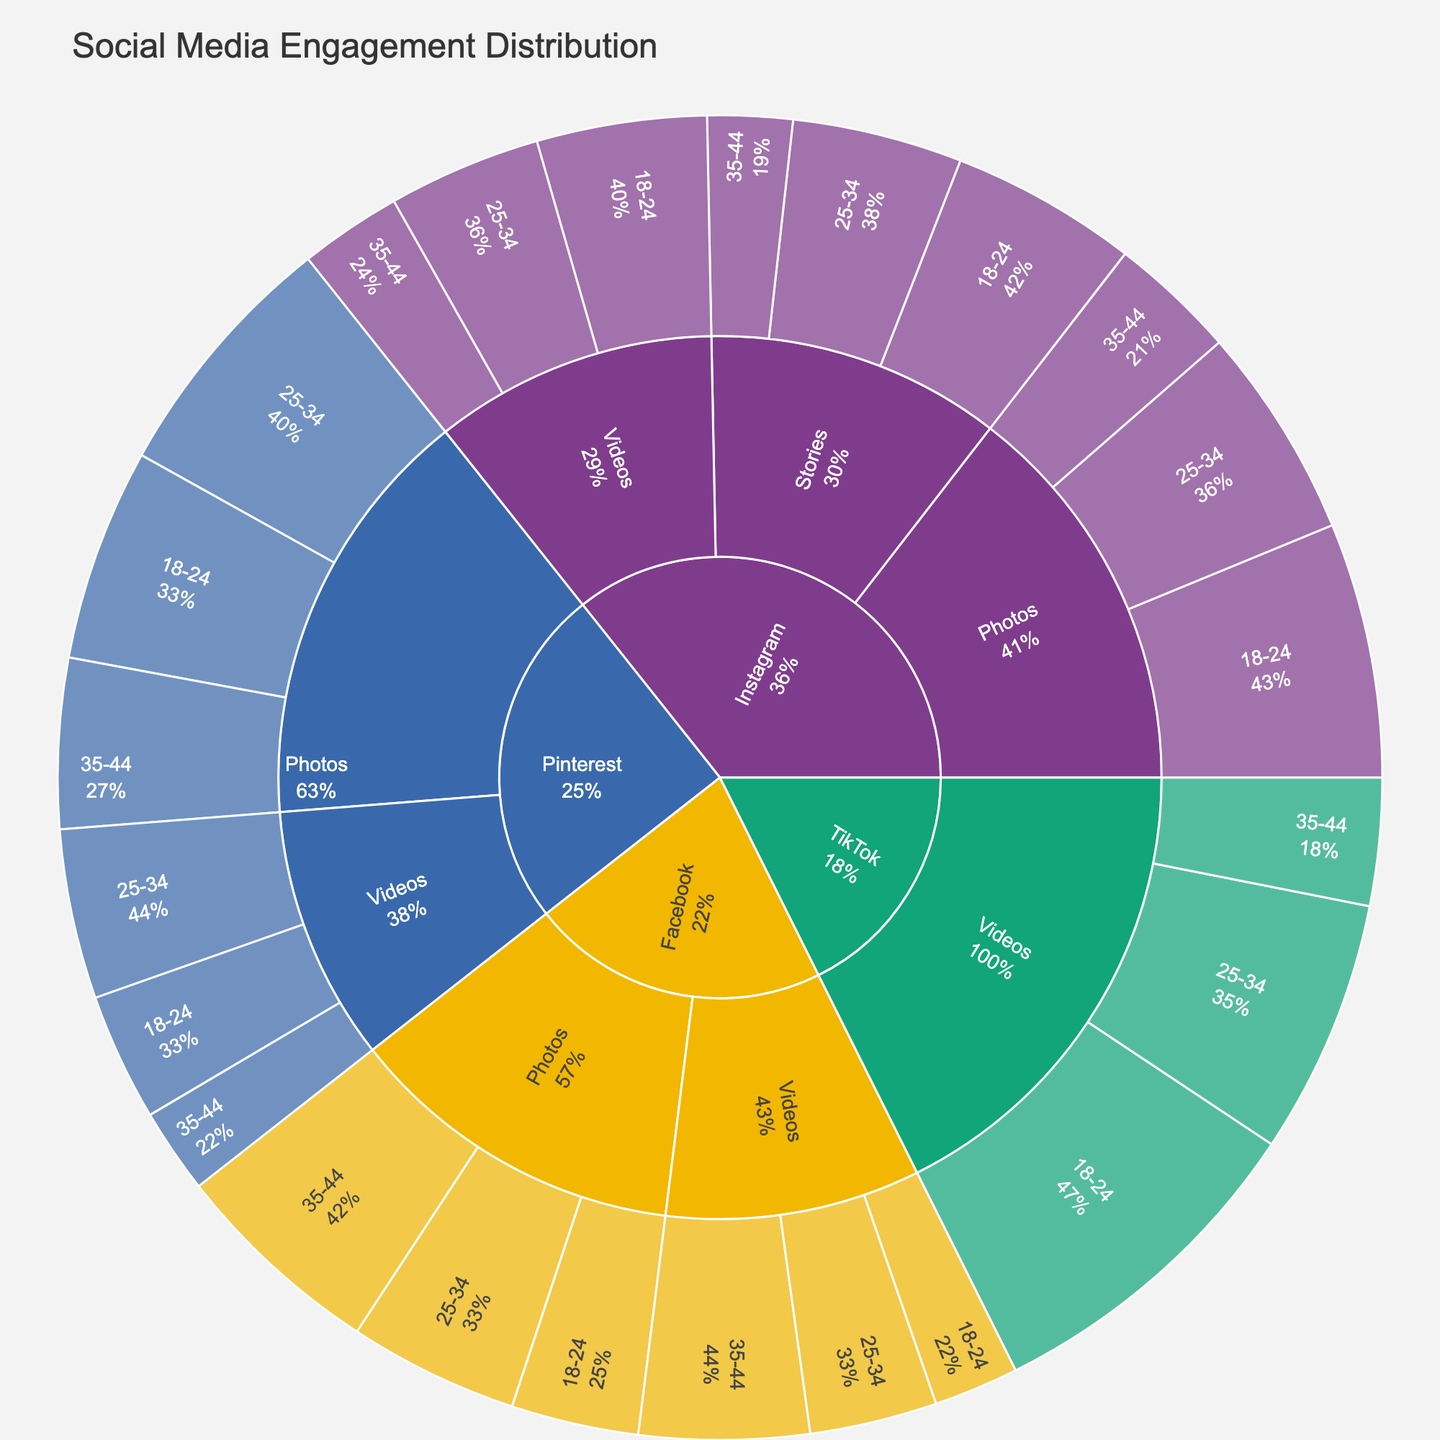what is the title of the plot? The title is displayed at the top of the plot. It summarizes the subject of the plot, providing context for what the data represents. In this case, it should be clearly visible as "Social Media Engagement Distribution."
Answer: Social Media Engagement Distribution Which platform has the highest engagement for the "18-24" demographic? To find this, look for the segment corresponding to the 18-24 demographic under each platform and compare their sizes. The "18-24" demographic under TikTok has the largest segment, indicating the highest engagement.
Answer: TikTok What's the total engagement for "Instagram" for all content types? To calculate this, sum the engagements for all demographics under each content type for Instagram. For photos: 30+25+15 = 70, Videos: 20+18+12 = 50, Stories: 22+20+10 = 52. Then, total is 70+50+52 = 172.
Answer: 172 Between "Photos" and "Videos", which content type has higher engagement on "Pinterest" and by how much? Compare total engagement values for both content types under Pinterest. Photos: 25+30+20=75, Videos: 15+20+10=45. Subtract the smaller total from the larger one to find the difference: 75 - 45 = 30.
Answer: Photos by 30 What are the three largest segments for "Facebook"? To identify the largest segments, compare all segments under Facebook in terms of engagement values. The three largest are Photos for 35-44 (25), Photos for 25-34 (20), and Videos for 35-44 (20).
Answer: Photos (35-44), Photos (25-34), Videos (35-44) Which content type has the least engagement on "Instagram"? To find this, compare the total engagement values of each content type on Instagram. Photos: 70, Videos: 50, Stories: 52. The least engagement is for Videos with a value of 50.
Answer: Videos What is the average engagement for "Videos" across all platforms? Calculate the engagement for Videos across all platforms and appreciate the total first. Instagram: 20+18+12=50, TikTok: 40+30+15=85, Facebook: 10+15+20=45, Pinterest: 15+20+10=45. Total: 50+85+45+45=225. Then, divide by the number of platforms: 225/4 = 56.25.
Answer: 56.25 Which platform has the highest total engagement? Sum all the engagement values for each platform and identify the highest. Instagram: 172, TikTok: 85, Facebook: 105, Pinterest: 120. The highest total engagement is for Instagram with 172.
Answer: Instagram What proportion of total "TikTok" engagement comes from the "25-34" demographic? First, find the total engagement for TikTok: 40+30+15=85. Next, identify the engagement for the 25-34 demographic (30). Calculate the proportion: 30/85 and convert to a percentage. 30/85 ≈ 0.353, or about 35.3%.
Answer: 35.3% Which audience demographic has the highest engagement across all platforms? To determine this, sum the engagements for the same demographic across all platforms. 18-24: 30+20+22+40+15+10+25+15=177, 25-34: 25+18+20+30+20+15+30+20=178, 35-44: 15+12+10+15+25+20+20+10=127. The demographic with highest engagement is 25-34 with 178.
Answer: 25-34 